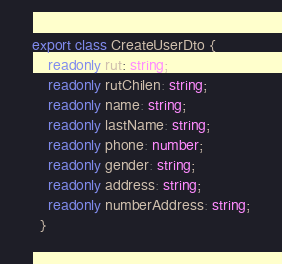Convert code to text. <code><loc_0><loc_0><loc_500><loc_500><_TypeScript_>export class CreateUserDto {
    readonly rut: string;
    readonly rutChilen: string;
    readonly name: string;
    readonly lastName: string;
    readonly phone: number;
    readonly gender: string;
    readonly address: string;
    readonly numberAddress: string;
  }</code> 